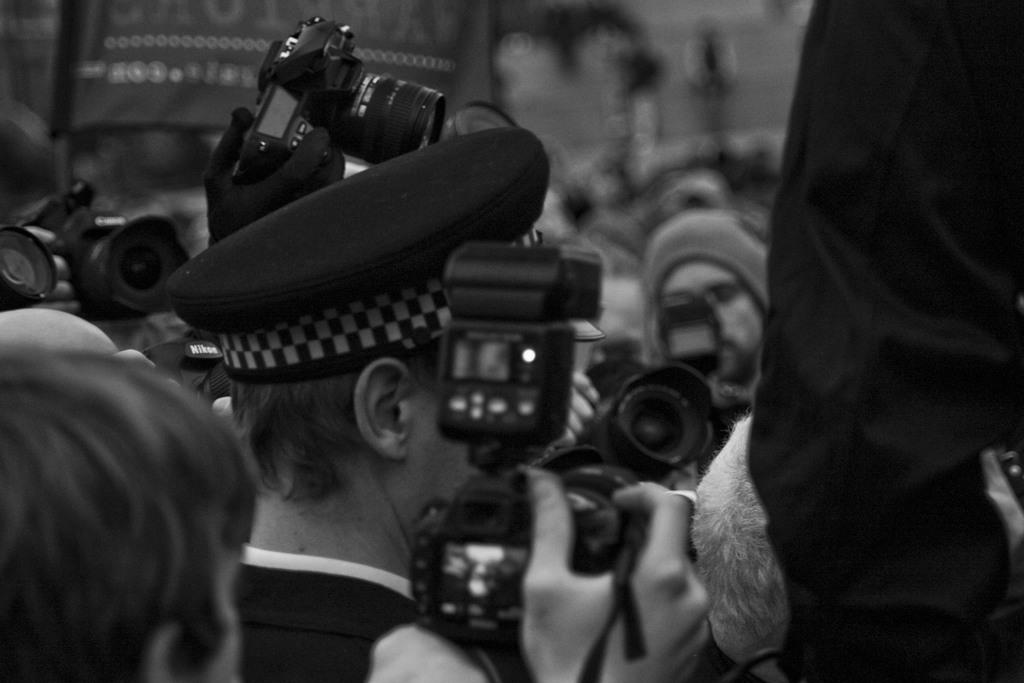What can be observed about the people in the image? There are people in the image, and most of them are holding cameras in their hands. Can you describe any specific clothing or accessories worn by the people in the image? Yes, there is a person wearing a cap in the image. How many spiders are crawling on the people in the image? There are no spiders visible in the image; the people are holding cameras and there is a person wearing a cap. What type of muscle is being exercised by the people in the image? The image does not show any specific muscles being exercised; it primarily focuses on the people holding cameras. 